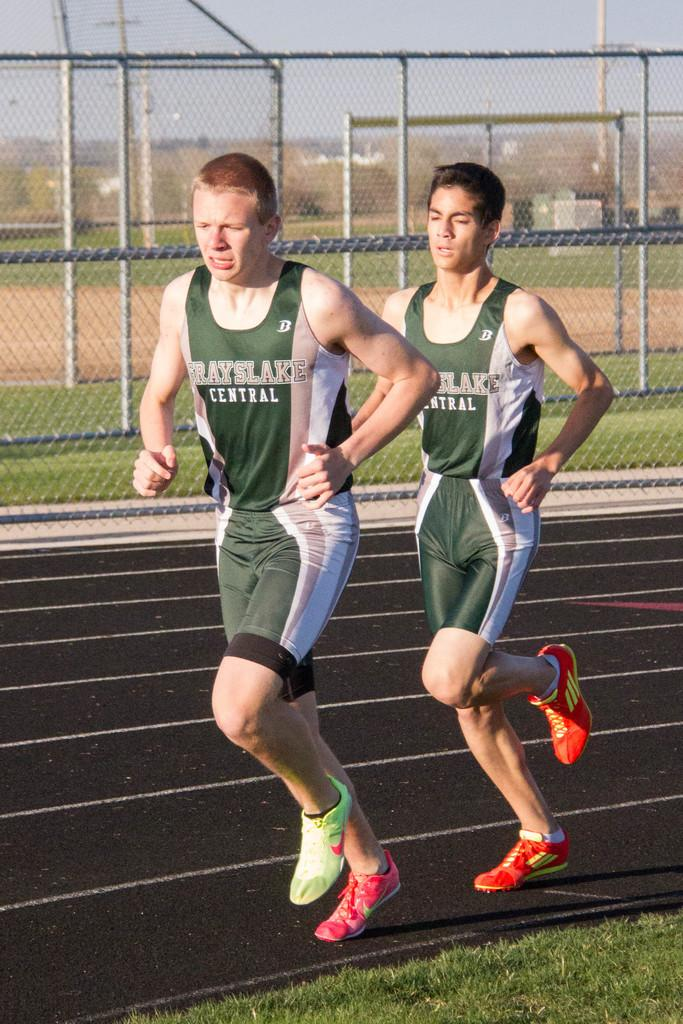<image>
Summarize the visual content of the image. two Grayslake Central runners on the track in green and white uniforms 